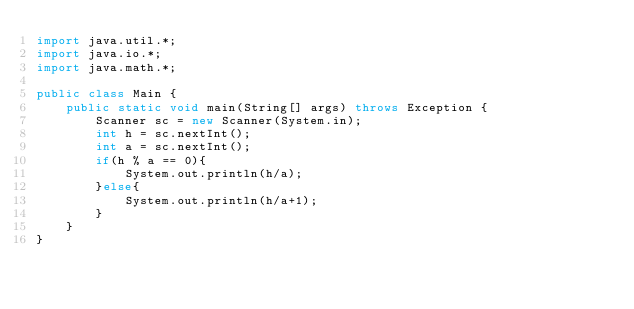<code> <loc_0><loc_0><loc_500><loc_500><_Java_>import java.util.*;
import java.io.*;
import java.math.*;
 
public class Main {
    public static void main(String[] args) throws Exception {
        Scanner sc = new Scanner(System.in);
        int h = sc.nextInt();
        int a = sc.nextInt();
        if(h % a == 0){
            System.out.println(h/a);
        }else{
            System.out.println(h/a+1);
        }
    }
}</code> 